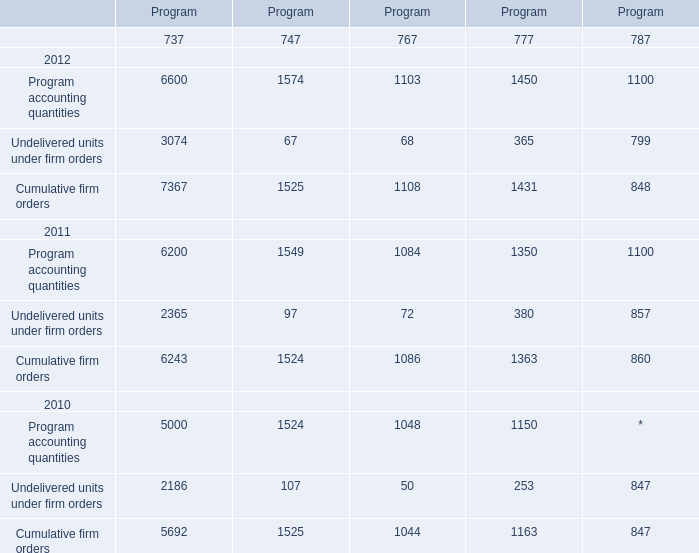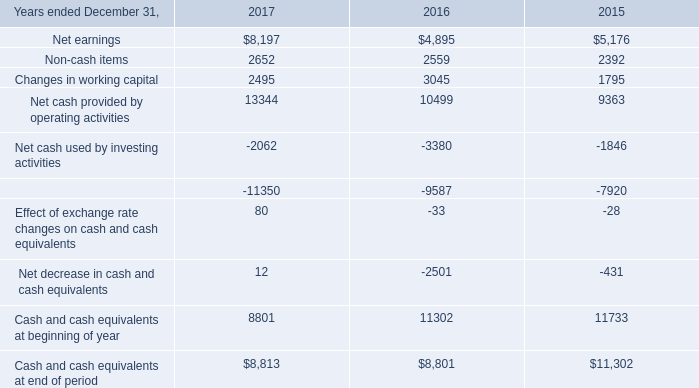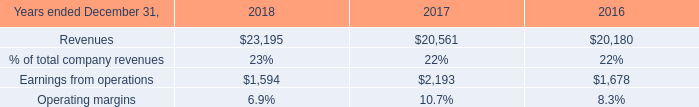What's the increasing rate of Cumulative firm orders of Program737 in 2012? 
Computations: ((7367 - 6243) / 6243)
Answer: 0.18004. 